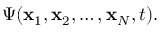<formula> <loc_0><loc_0><loc_500><loc_500>\Psi ( { x } _ { 1 } , { x } _ { 2 } , \dots , { x } _ { N } , t ) .</formula> 